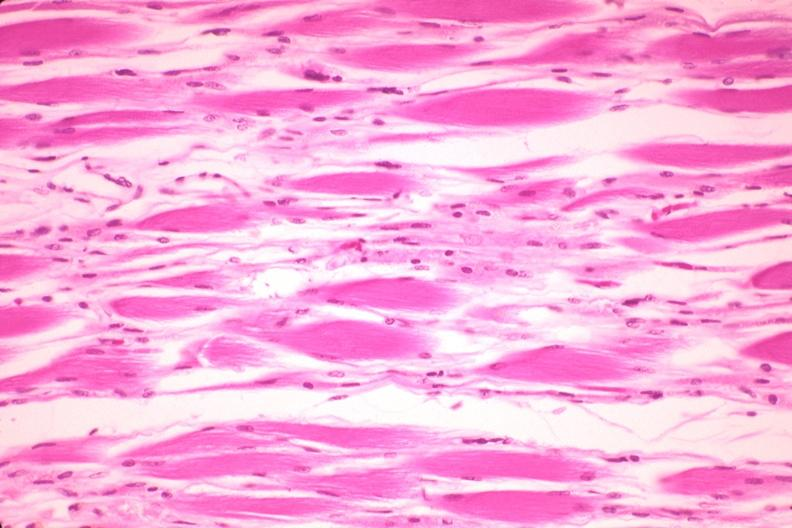why does this image show high excellent atrophy?
Answer the question using a single word or phrase. Due to steroid therapy 